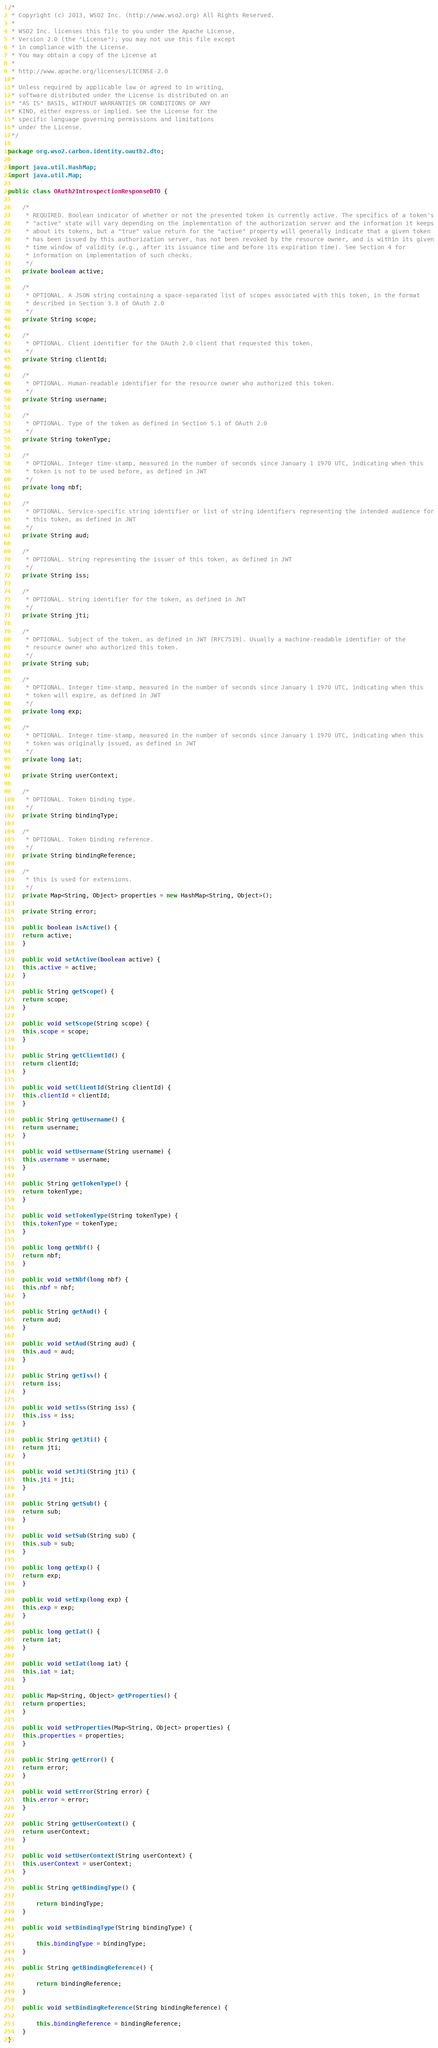Convert code to text. <code><loc_0><loc_0><loc_500><loc_500><_Java_>/*
 * Copyright (c) 2013, WSO2 Inc. (http://www.wso2.org) All Rights Reserved.
 *
 * WSO2 Inc. licenses this file to you under the Apache License,
 * Version 2.0 (the "License"); you may not use this file except
 * in compliance with the License.
 * You may obtain a copy of the License at
 *
 * http://www.apache.org/licenses/LICENSE-2.0
 *
 * Unless required by applicable law or agreed to in writing,
 * software distributed under the License is distributed on an
 * "AS IS" BASIS, WITHOUT WARRANTIES OR CONDITIONS OF ANY
 * KIND, either express or implied. See the License for the
 * specific language governing permissions and limitations
 * under the License.
 */

package org.wso2.carbon.identity.oauth2.dto;

import java.util.HashMap;
import java.util.Map;

public class OAuth2IntrospectionResponseDTO {

    /*
     * REQUIRED. Boolean indicator of whether or not the presented token is currently active. The specifics of a token's
     * "active" state will vary depending on the implementation of the authorization server and the information it keeps
     * about its tokens, but a "true" value return for the "active" property will generally indicate that a given token
     * has been issued by this authorization server, has not been revoked by the resource owner, and is within its given
     * time window of validity (e.g., after its issuance time and before its expiration time). See Section 4 for
     * information on implementation of such checks.
     */
    private boolean active;

    /*
     * OPTIONAL. A JSON string containing a space-separated list of scopes associated with this token, in the format
     * described in Section 3.3 of OAuth 2.0
     */
    private String scope;

    /*
     * OPTIONAL. Client identifier for the OAuth 2.0 client that requested this token.
     */
    private String clientId;

    /*
     * OPTIONAL. Human-readable identifier for the resource owner who authorized this token.
     */
    private String username;

    /*
     * OPTIONAL. Type of the token as defined in Section 5.1 of OAuth 2.0
     */
    private String tokenType;

    /*
     * OPTIONAL. Integer time-stamp, measured in the number of seconds since January 1 1970 UTC, indicating when this
     * token is not to be used before, as defined in JWT
     */
    private long nbf;

    /*
     * OPTIONAL. Service-specific string identifier or list of string identifiers representing the intended audience for
     * this token, as defined in JWT
     */
    private String aud;

    /*
     * OPTIONAL. String representing the issuer of this token, as defined in JWT
     */
    private String iss;

    /*
     * OPTIONAL. String identifier for the token, as defined in JWT
     */
    private String jti;

    /*
     * OPTIONAL. Subject of the token, as defined in JWT [RFC7519]. Usually a machine-readable identifier of the
     * resource owner who authorized this token.
     */
    private String sub;

    /*
     * OPTIONAL. Integer time-stamp, measured in the number of seconds since January 1 1970 UTC, indicating when this
     * token will expire, as defined in JWT
     */
    private long exp;

    /*
     * OPTIONAL. Integer time-stamp, measured in the number of seconds since January 1 1970 UTC, indicating when this
     * token was originally issued, as defined in JWT
     */
    private long iat;

    private String userContext;

    /*
     * OPTIONAL. Token binding type.
     */
    private String bindingType;

    /*
     * OPTIONAL. Token binding reference.
     */
    private String bindingReference;

    /*
     * this is used for extensions.
     */
    private Map<String, Object> properties = new HashMap<String, Object>();

    private String error;

    public boolean isActive() {
	return active;
    }

    public void setActive(boolean active) {
	this.active = active;
    }

    public String getScope() {
	return scope;
    }

    public void setScope(String scope) {
	this.scope = scope;
    }

    public String getClientId() {
	return clientId;
    }

    public void setClientId(String clientId) {
	this.clientId = clientId;
    }

    public String getUsername() {
	return username;
    }

    public void setUsername(String username) {
	this.username = username;
    }

    public String getTokenType() {
	return tokenType;
    }

    public void setTokenType(String tokenType) {
	this.tokenType = tokenType;
    }

    public long getNbf() {
	return nbf;
    }

    public void setNbf(long nbf) {
	this.nbf = nbf;
    }

    public String getAud() {
	return aud;
    }

    public void setAud(String aud) {
	this.aud = aud;
    }

    public String getIss() {
	return iss;
    }

    public void setIss(String iss) {
	this.iss = iss;
    }

    public String getJti() {
	return jti;
    }

    public void setJti(String jti) {
	this.jti = jti;
    }

    public String getSub() {
	return sub;
    }

    public void setSub(String sub) {
	this.sub = sub;
    }

    public long getExp() {
	return exp;
    }

    public void setExp(long exp) {
	this.exp = exp;
    }

    public long getIat() {
	return iat;
    }

    public void setIat(long iat) {
	this.iat = iat;
    }

    public Map<String, Object> getProperties() {
	return properties;
    }

    public void setProperties(Map<String, Object> properties) {
	this.properties = properties;
    }

    public String getError() {
	return error;
    }

    public void setError(String error) {
	this.error = error;
    }

    public String getUserContext() {
	return userContext;
    }

    public void setUserContext(String userContext) {
	this.userContext = userContext;
    }

    public String getBindingType() {

        return bindingType;
    }

    public void setBindingType(String bindingType) {

        this.bindingType = bindingType;
    }

    public String getBindingReference() {

        return bindingReference;
    }

    public void setBindingReference(String bindingReference) {

        this.bindingReference = bindingReference;
    }
}
</code> 